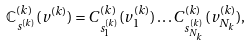Convert formula to latex. <formula><loc_0><loc_0><loc_500><loc_500>\mathbb { C } ^ { ( k ) } _ { s ^ { ( k ) } } ( v ^ { ( k ) } ) = C ^ { ( k ) } _ { s ^ { ( k ) } _ { 1 } } ( v ^ { ( k ) } _ { 1 } ) \dots C ^ { ( k ) } _ { s ^ { ( k ) } _ { N _ { k } } } ( v ^ { ( k ) } _ { N _ { k } } ) ,</formula> 